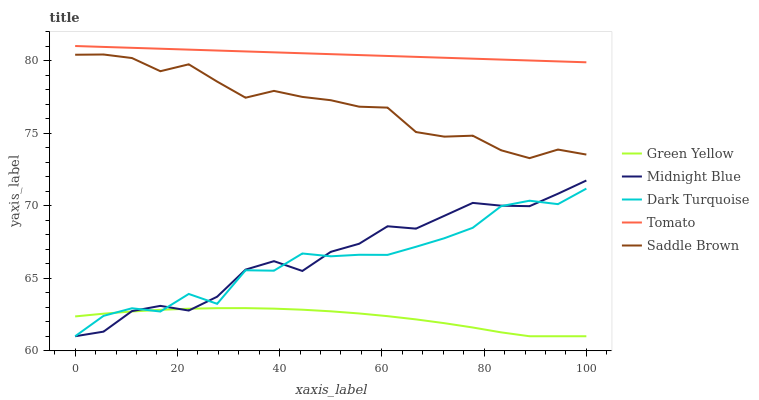Does Green Yellow have the minimum area under the curve?
Answer yes or no. Yes. Does Tomato have the maximum area under the curve?
Answer yes or no. Yes. Does Dark Turquoise have the minimum area under the curve?
Answer yes or no. No. Does Dark Turquoise have the maximum area under the curve?
Answer yes or no. No. Is Tomato the smoothest?
Answer yes or no. Yes. Is Dark Turquoise the roughest?
Answer yes or no. Yes. Is Green Yellow the smoothest?
Answer yes or no. No. Is Green Yellow the roughest?
Answer yes or no. No. Does Saddle Brown have the lowest value?
Answer yes or no. No. Does Tomato have the highest value?
Answer yes or no. Yes. Does Dark Turquoise have the highest value?
Answer yes or no. No. Is Dark Turquoise less than Tomato?
Answer yes or no. Yes. Is Saddle Brown greater than Midnight Blue?
Answer yes or no. Yes. Does Dark Turquoise intersect Tomato?
Answer yes or no. No. 